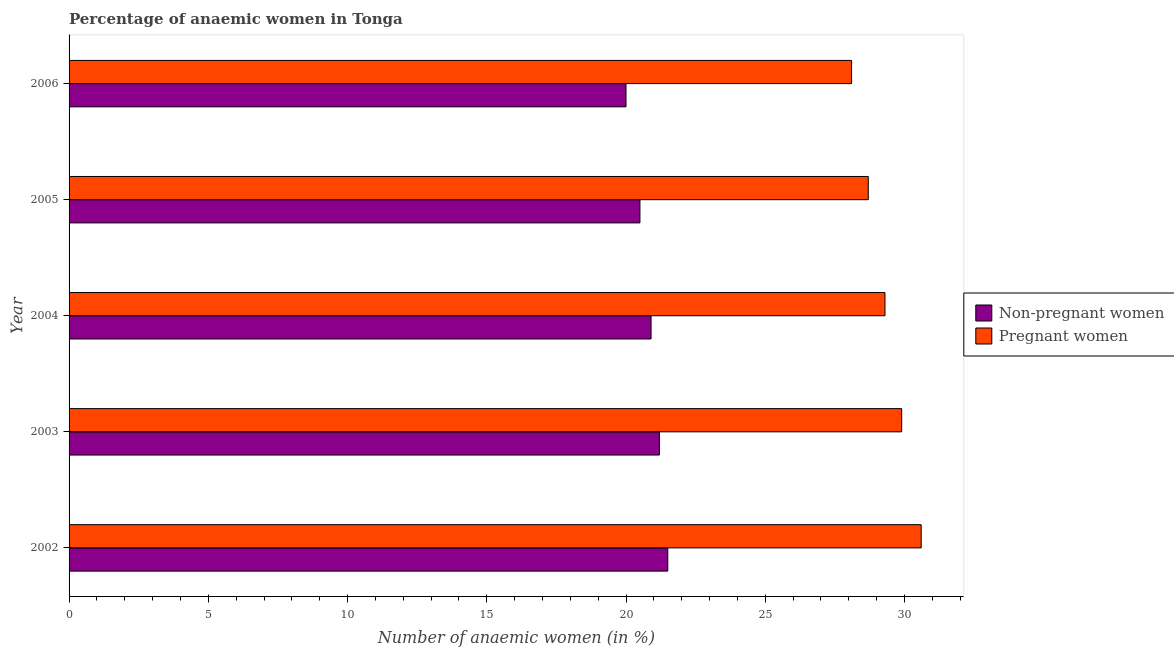How many different coloured bars are there?
Your answer should be very brief. 2. What is the label of the 5th group of bars from the top?
Provide a succinct answer. 2002. In how many cases, is the number of bars for a given year not equal to the number of legend labels?
Your answer should be very brief. 0. What is the percentage of pregnant anaemic women in 2002?
Provide a short and direct response. 30.6. Across all years, what is the maximum percentage of non-pregnant anaemic women?
Your answer should be compact. 21.5. Across all years, what is the minimum percentage of non-pregnant anaemic women?
Offer a very short reply. 20. What is the total percentage of pregnant anaemic women in the graph?
Give a very brief answer. 146.6. What is the difference between the percentage of pregnant anaemic women in 2004 and the percentage of non-pregnant anaemic women in 2006?
Your answer should be very brief. 9.3. What is the average percentage of pregnant anaemic women per year?
Your answer should be very brief. 29.32. In the year 2005, what is the difference between the percentage of pregnant anaemic women and percentage of non-pregnant anaemic women?
Offer a very short reply. 8.2. What is the ratio of the percentage of pregnant anaemic women in 2003 to that in 2006?
Give a very brief answer. 1.06. Is the percentage of pregnant anaemic women in 2002 less than that in 2003?
Provide a succinct answer. No. Is the difference between the percentage of non-pregnant anaemic women in 2002 and 2006 greater than the difference between the percentage of pregnant anaemic women in 2002 and 2006?
Make the answer very short. No. What is the difference between the highest and the lowest percentage of pregnant anaemic women?
Provide a succinct answer. 2.5. What does the 1st bar from the top in 2003 represents?
Your answer should be compact. Pregnant women. What does the 1st bar from the bottom in 2003 represents?
Your response must be concise. Non-pregnant women. Does the graph contain any zero values?
Give a very brief answer. No. Does the graph contain grids?
Offer a terse response. No. Where does the legend appear in the graph?
Keep it short and to the point. Center right. How many legend labels are there?
Provide a succinct answer. 2. How are the legend labels stacked?
Keep it short and to the point. Vertical. What is the title of the graph?
Keep it short and to the point. Percentage of anaemic women in Tonga. Does "Electricity and heat production" appear as one of the legend labels in the graph?
Give a very brief answer. No. What is the label or title of the X-axis?
Keep it short and to the point. Number of anaemic women (in %). What is the label or title of the Y-axis?
Provide a succinct answer. Year. What is the Number of anaemic women (in %) in Non-pregnant women in 2002?
Give a very brief answer. 21.5. What is the Number of anaemic women (in %) in Pregnant women in 2002?
Ensure brevity in your answer.  30.6. What is the Number of anaemic women (in %) of Non-pregnant women in 2003?
Provide a short and direct response. 21.2. What is the Number of anaemic women (in %) of Pregnant women in 2003?
Your response must be concise. 29.9. What is the Number of anaemic women (in %) of Non-pregnant women in 2004?
Give a very brief answer. 20.9. What is the Number of anaemic women (in %) of Pregnant women in 2004?
Your response must be concise. 29.3. What is the Number of anaemic women (in %) in Pregnant women in 2005?
Provide a short and direct response. 28.7. What is the Number of anaemic women (in %) in Non-pregnant women in 2006?
Your answer should be compact. 20. What is the Number of anaemic women (in %) in Pregnant women in 2006?
Your response must be concise. 28.1. Across all years, what is the maximum Number of anaemic women (in %) in Non-pregnant women?
Make the answer very short. 21.5. Across all years, what is the maximum Number of anaemic women (in %) in Pregnant women?
Offer a very short reply. 30.6. Across all years, what is the minimum Number of anaemic women (in %) in Pregnant women?
Your answer should be very brief. 28.1. What is the total Number of anaemic women (in %) of Non-pregnant women in the graph?
Keep it short and to the point. 104.1. What is the total Number of anaemic women (in %) of Pregnant women in the graph?
Provide a succinct answer. 146.6. What is the difference between the Number of anaemic women (in %) in Non-pregnant women in 2002 and that in 2003?
Keep it short and to the point. 0.3. What is the difference between the Number of anaemic women (in %) in Non-pregnant women in 2002 and that in 2004?
Ensure brevity in your answer.  0.6. What is the difference between the Number of anaemic women (in %) of Pregnant women in 2002 and that in 2005?
Offer a very short reply. 1.9. What is the difference between the Number of anaemic women (in %) in Non-pregnant women in 2002 and that in 2006?
Offer a very short reply. 1.5. What is the difference between the Number of anaemic women (in %) in Pregnant women in 2002 and that in 2006?
Give a very brief answer. 2.5. What is the difference between the Number of anaemic women (in %) in Non-pregnant women in 2003 and that in 2004?
Keep it short and to the point. 0.3. What is the difference between the Number of anaemic women (in %) of Pregnant women in 2003 and that in 2005?
Make the answer very short. 1.2. What is the difference between the Number of anaemic women (in %) of Non-pregnant women in 2003 and that in 2006?
Ensure brevity in your answer.  1.2. What is the difference between the Number of anaemic women (in %) of Pregnant women in 2004 and that in 2006?
Ensure brevity in your answer.  1.2. What is the difference between the Number of anaemic women (in %) in Non-pregnant women in 2002 and the Number of anaemic women (in %) in Pregnant women in 2005?
Your answer should be very brief. -7.2. What is the difference between the Number of anaemic women (in %) in Non-pregnant women in 2003 and the Number of anaemic women (in %) in Pregnant women in 2004?
Ensure brevity in your answer.  -8.1. What is the difference between the Number of anaemic women (in %) of Non-pregnant women in 2005 and the Number of anaemic women (in %) of Pregnant women in 2006?
Provide a succinct answer. -7.6. What is the average Number of anaemic women (in %) of Non-pregnant women per year?
Your answer should be compact. 20.82. What is the average Number of anaemic women (in %) in Pregnant women per year?
Provide a succinct answer. 29.32. In the year 2006, what is the difference between the Number of anaemic women (in %) of Non-pregnant women and Number of anaemic women (in %) of Pregnant women?
Your answer should be very brief. -8.1. What is the ratio of the Number of anaemic women (in %) of Non-pregnant women in 2002 to that in 2003?
Your response must be concise. 1.01. What is the ratio of the Number of anaemic women (in %) of Pregnant women in 2002 to that in 2003?
Make the answer very short. 1.02. What is the ratio of the Number of anaemic women (in %) in Non-pregnant women in 2002 to that in 2004?
Keep it short and to the point. 1.03. What is the ratio of the Number of anaemic women (in %) in Pregnant women in 2002 to that in 2004?
Your answer should be very brief. 1.04. What is the ratio of the Number of anaemic women (in %) of Non-pregnant women in 2002 to that in 2005?
Your answer should be compact. 1.05. What is the ratio of the Number of anaemic women (in %) of Pregnant women in 2002 to that in 2005?
Ensure brevity in your answer.  1.07. What is the ratio of the Number of anaemic women (in %) in Non-pregnant women in 2002 to that in 2006?
Ensure brevity in your answer.  1.07. What is the ratio of the Number of anaemic women (in %) of Pregnant women in 2002 to that in 2006?
Your answer should be compact. 1.09. What is the ratio of the Number of anaemic women (in %) of Non-pregnant women in 2003 to that in 2004?
Provide a short and direct response. 1.01. What is the ratio of the Number of anaemic women (in %) of Pregnant women in 2003 to that in 2004?
Provide a succinct answer. 1.02. What is the ratio of the Number of anaemic women (in %) in Non-pregnant women in 2003 to that in 2005?
Make the answer very short. 1.03. What is the ratio of the Number of anaemic women (in %) in Pregnant women in 2003 to that in 2005?
Offer a very short reply. 1.04. What is the ratio of the Number of anaemic women (in %) of Non-pregnant women in 2003 to that in 2006?
Provide a short and direct response. 1.06. What is the ratio of the Number of anaemic women (in %) of Pregnant women in 2003 to that in 2006?
Give a very brief answer. 1.06. What is the ratio of the Number of anaemic women (in %) in Non-pregnant women in 2004 to that in 2005?
Ensure brevity in your answer.  1.02. What is the ratio of the Number of anaemic women (in %) in Pregnant women in 2004 to that in 2005?
Offer a terse response. 1.02. What is the ratio of the Number of anaemic women (in %) in Non-pregnant women in 2004 to that in 2006?
Ensure brevity in your answer.  1.04. What is the ratio of the Number of anaemic women (in %) in Pregnant women in 2004 to that in 2006?
Your answer should be very brief. 1.04. What is the ratio of the Number of anaemic women (in %) in Non-pregnant women in 2005 to that in 2006?
Provide a short and direct response. 1.02. What is the ratio of the Number of anaemic women (in %) of Pregnant women in 2005 to that in 2006?
Give a very brief answer. 1.02. What is the difference between the highest and the second highest Number of anaemic women (in %) in Non-pregnant women?
Your response must be concise. 0.3. What is the difference between the highest and the second highest Number of anaemic women (in %) in Pregnant women?
Your answer should be very brief. 0.7. 